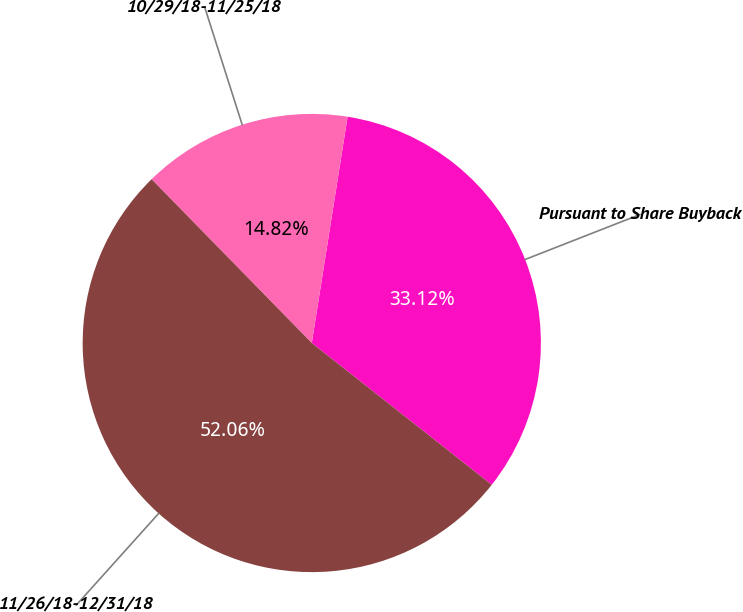<chart> <loc_0><loc_0><loc_500><loc_500><pie_chart><fcel>Pursuant to Share Buyback<fcel>10/29/18-11/25/18<fcel>11/26/18-12/31/18<nl><fcel>33.12%<fcel>14.82%<fcel>52.05%<nl></chart> 